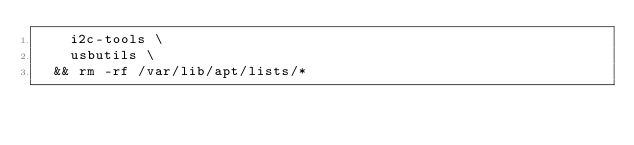Convert code to text. <code><loc_0><loc_0><loc_500><loc_500><_Dockerfile_>		i2c-tools \
		usbutils \
	&& rm -rf /var/lib/apt/lists/*</code> 